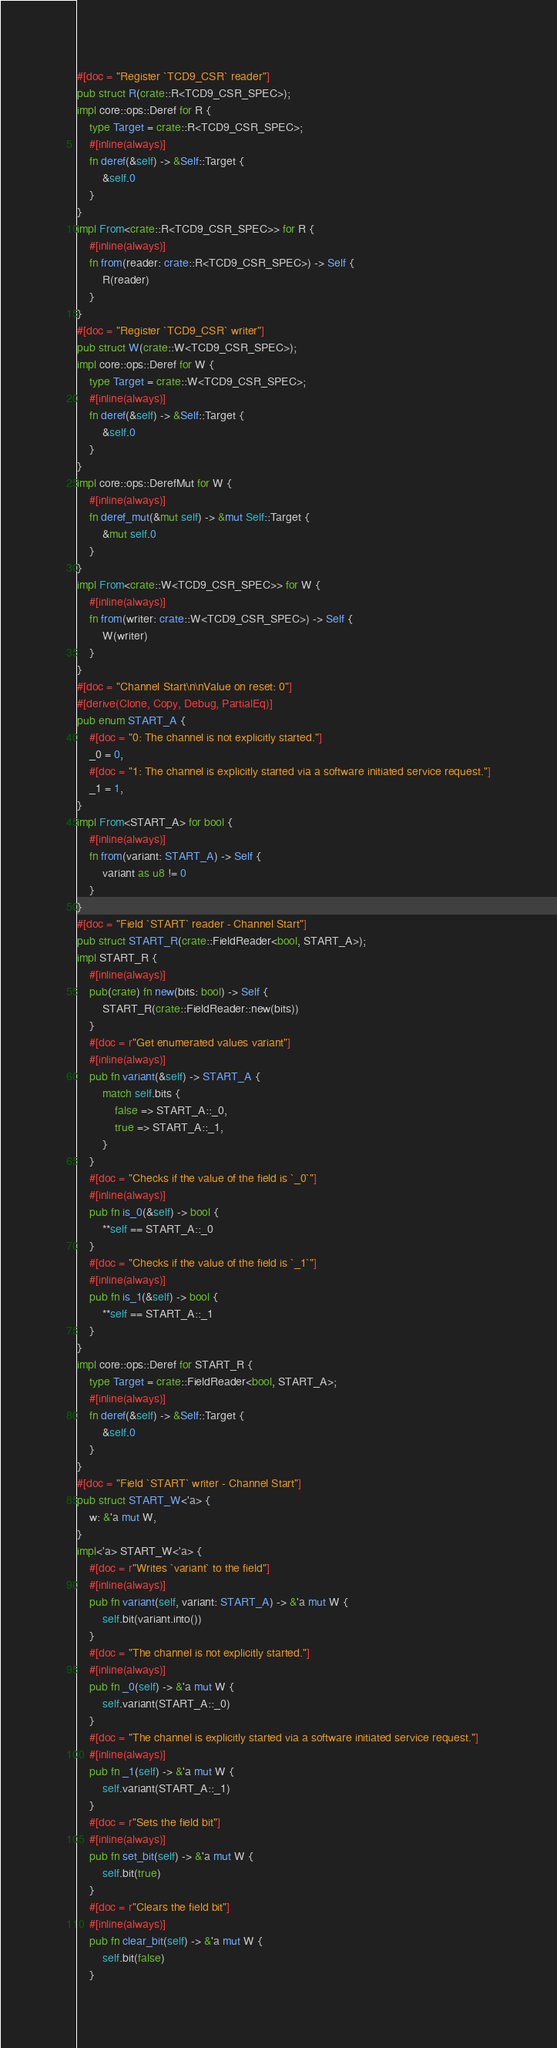<code> <loc_0><loc_0><loc_500><loc_500><_Rust_>#[doc = "Register `TCD9_CSR` reader"]
pub struct R(crate::R<TCD9_CSR_SPEC>);
impl core::ops::Deref for R {
    type Target = crate::R<TCD9_CSR_SPEC>;
    #[inline(always)]
    fn deref(&self) -> &Self::Target {
        &self.0
    }
}
impl From<crate::R<TCD9_CSR_SPEC>> for R {
    #[inline(always)]
    fn from(reader: crate::R<TCD9_CSR_SPEC>) -> Self {
        R(reader)
    }
}
#[doc = "Register `TCD9_CSR` writer"]
pub struct W(crate::W<TCD9_CSR_SPEC>);
impl core::ops::Deref for W {
    type Target = crate::W<TCD9_CSR_SPEC>;
    #[inline(always)]
    fn deref(&self) -> &Self::Target {
        &self.0
    }
}
impl core::ops::DerefMut for W {
    #[inline(always)]
    fn deref_mut(&mut self) -> &mut Self::Target {
        &mut self.0
    }
}
impl From<crate::W<TCD9_CSR_SPEC>> for W {
    #[inline(always)]
    fn from(writer: crate::W<TCD9_CSR_SPEC>) -> Self {
        W(writer)
    }
}
#[doc = "Channel Start\n\nValue on reset: 0"]
#[derive(Clone, Copy, Debug, PartialEq)]
pub enum START_A {
    #[doc = "0: The channel is not explicitly started."]
    _0 = 0,
    #[doc = "1: The channel is explicitly started via a software initiated service request."]
    _1 = 1,
}
impl From<START_A> for bool {
    #[inline(always)]
    fn from(variant: START_A) -> Self {
        variant as u8 != 0
    }
}
#[doc = "Field `START` reader - Channel Start"]
pub struct START_R(crate::FieldReader<bool, START_A>);
impl START_R {
    #[inline(always)]
    pub(crate) fn new(bits: bool) -> Self {
        START_R(crate::FieldReader::new(bits))
    }
    #[doc = r"Get enumerated values variant"]
    #[inline(always)]
    pub fn variant(&self) -> START_A {
        match self.bits {
            false => START_A::_0,
            true => START_A::_1,
        }
    }
    #[doc = "Checks if the value of the field is `_0`"]
    #[inline(always)]
    pub fn is_0(&self) -> bool {
        **self == START_A::_0
    }
    #[doc = "Checks if the value of the field is `_1`"]
    #[inline(always)]
    pub fn is_1(&self) -> bool {
        **self == START_A::_1
    }
}
impl core::ops::Deref for START_R {
    type Target = crate::FieldReader<bool, START_A>;
    #[inline(always)]
    fn deref(&self) -> &Self::Target {
        &self.0
    }
}
#[doc = "Field `START` writer - Channel Start"]
pub struct START_W<'a> {
    w: &'a mut W,
}
impl<'a> START_W<'a> {
    #[doc = r"Writes `variant` to the field"]
    #[inline(always)]
    pub fn variant(self, variant: START_A) -> &'a mut W {
        self.bit(variant.into())
    }
    #[doc = "The channel is not explicitly started."]
    #[inline(always)]
    pub fn _0(self) -> &'a mut W {
        self.variant(START_A::_0)
    }
    #[doc = "The channel is explicitly started via a software initiated service request."]
    #[inline(always)]
    pub fn _1(self) -> &'a mut W {
        self.variant(START_A::_1)
    }
    #[doc = r"Sets the field bit"]
    #[inline(always)]
    pub fn set_bit(self) -> &'a mut W {
        self.bit(true)
    }
    #[doc = r"Clears the field bit"]
    #[inline(always)]
    pub fn clear_bit(self) -> &'a mut W {
        self.bit(false)
    }</code> 